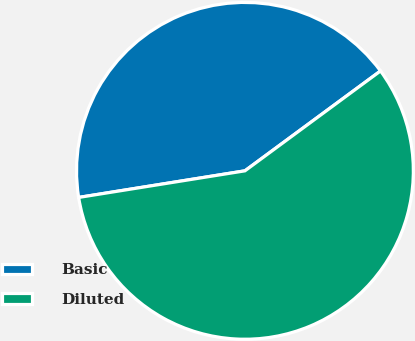<chart> <loc_0><loc_0><loc_500><loc_500><pie_chart><fcel>Basic<fcel>Diluted<nl><fcel>42.42%<fcel>57.58%<nl></chart> 